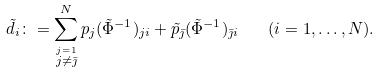Convert formula to latex. <formula><loc_0><loc_0><loc_500><loc_500>\tilde { d } _ { i } \colon = \sum _ { \stackrel { j = 1 } { j \neq \bar { \jmath } } } ^ { N } p _ { j } ( \tilde { \Phi } ^ { - 1 } ) _ { j i } + \tilde { p } _ { \bar { \jmath } } ( \tilde { \Phi } ^ { - 1 } ) _ { \bar { \jmath } i } \quad ( i = 1 , \dots , N ) .</formula> 